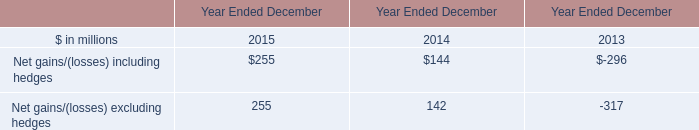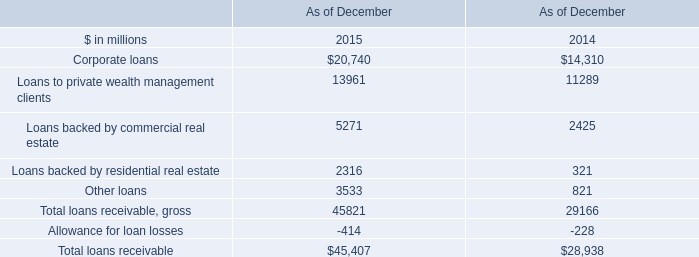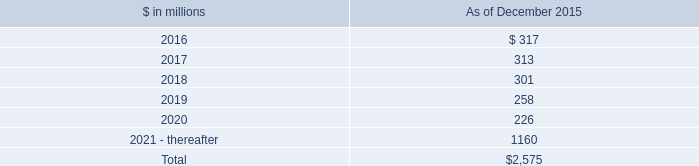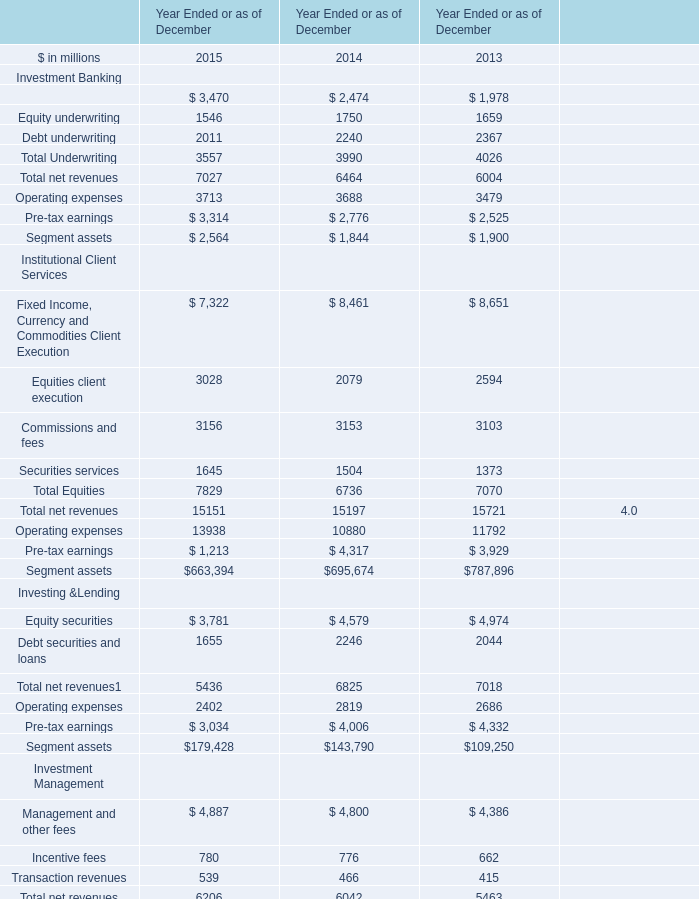What is the average value of Segment assets in 2015,2014 and 2013? (in million) 
Computations: (((663394 + 695674) + 787896) / 3)
Answer: 715654.66667. 